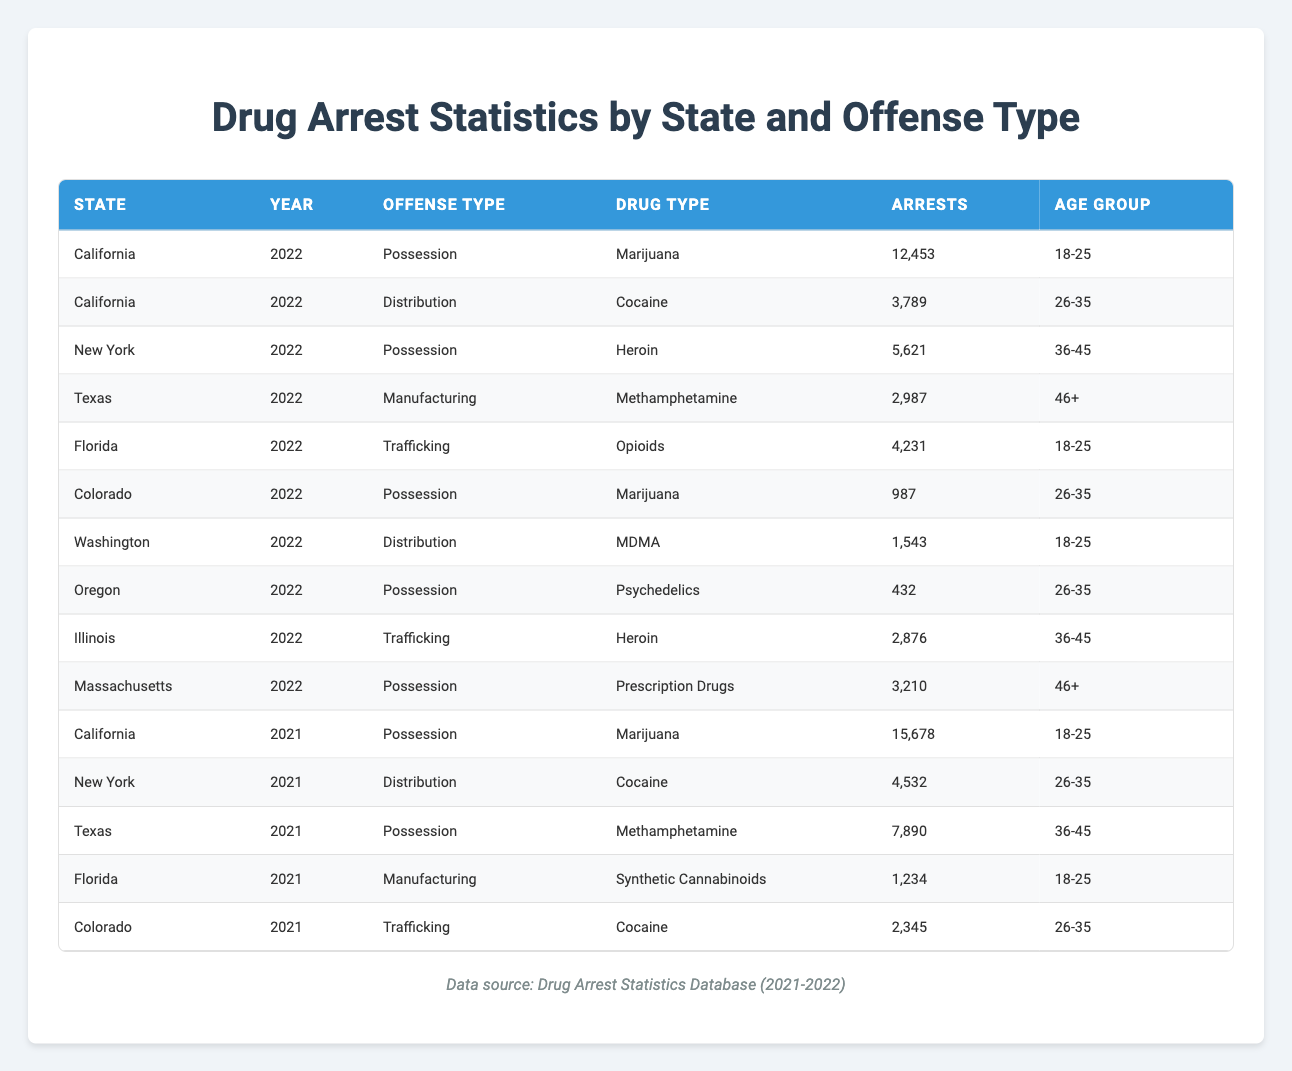What is the total number of marijuana possession arrests in California for 2022? In the table, we find California listed for the year 2022 with marijuana possession arrests of 12,453. We also have an entry for 2021 with 15,678 arrests, but since the question specifies 2022, we only consider the value from that year. So, the total for 2022 is simply the arrests listed, which is 12,453.
Answer: 12453 What is the sum of heroin possession and trafficking arrests in New York for 2022? In the table, New York has one entry for possession of heroin with 5,621 arrests in 2022. The table does not show any trafficking arrests for heroin in New York for 2022, indicating zero counts. Therefore, the calculation is 5,621 + 0 = 5,621.
Answer: 5621 Are there any drug arrests for psychedelics in Oregon in 2021? Upon inspecting the table, there is no entry for Oregon related to psychedelics in 2021. The only entry for psychedelics is for possession in 2022 with 432 arrests. Consequently, we can affirm that there are no arrests recorded for this drug type in 2021 for Oregon.
Answer: No Which state had the highest number of arrests for marijuana possession in 2021? In the table for 2021, California has 15,678 marijuana possession arrests, which is the only entry for that offense type. No other listed state reports marijuana possession arrests for 2021, leading us to conclude that California had the highest number.
Answer: California What is the average number of trafficking arrests across all drug types for Florida in 2021 and 2022? For Florida, the table shows one entry for trafficking in 2021 (1,234 arrests for synthetic cannabinoids) and one for 2022 (4,231 arrests for opioids). To calculate the average, we add the two values, 1,234 + 4,231 = 5,465, and divide by 2 for the average: 5,465 / 2 = 2,732.5. Thus, the average is 2,732.5.
Answer: 2732.5 